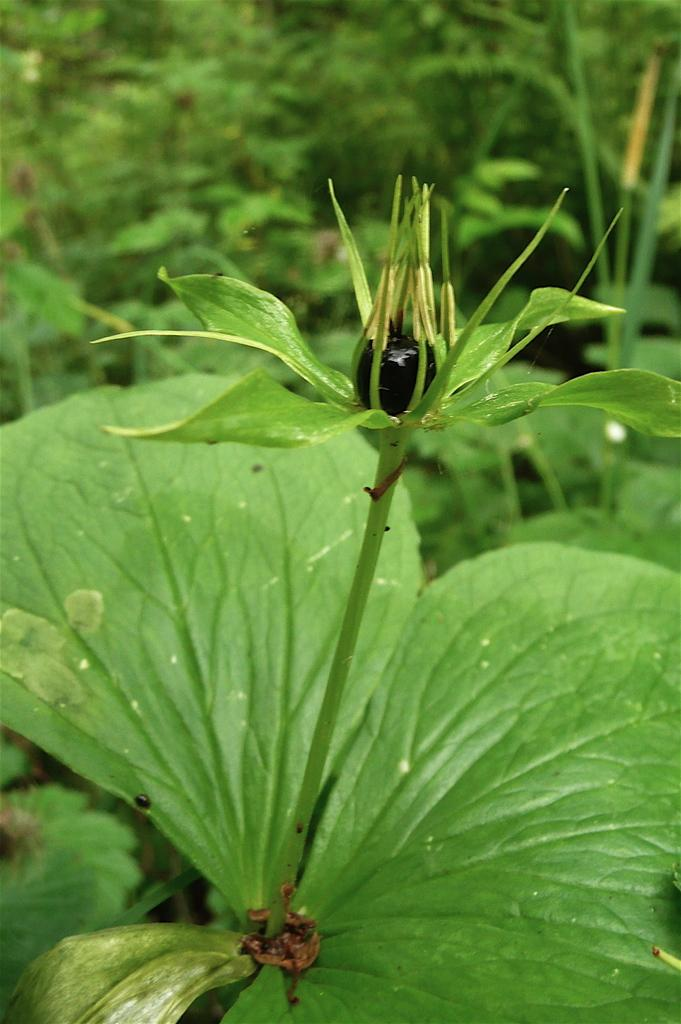What is the main subject of the image? The main subject of the image is a bud. Is the bud connected to anything? Yes, the bud is attached to a stem. What can be seen in the background of the image? There are trees visible behind the bud. What type of bag is hanging from the branch next to the bud? There is no bag present in the image; it only features a bud, stem, and trees in the background. 